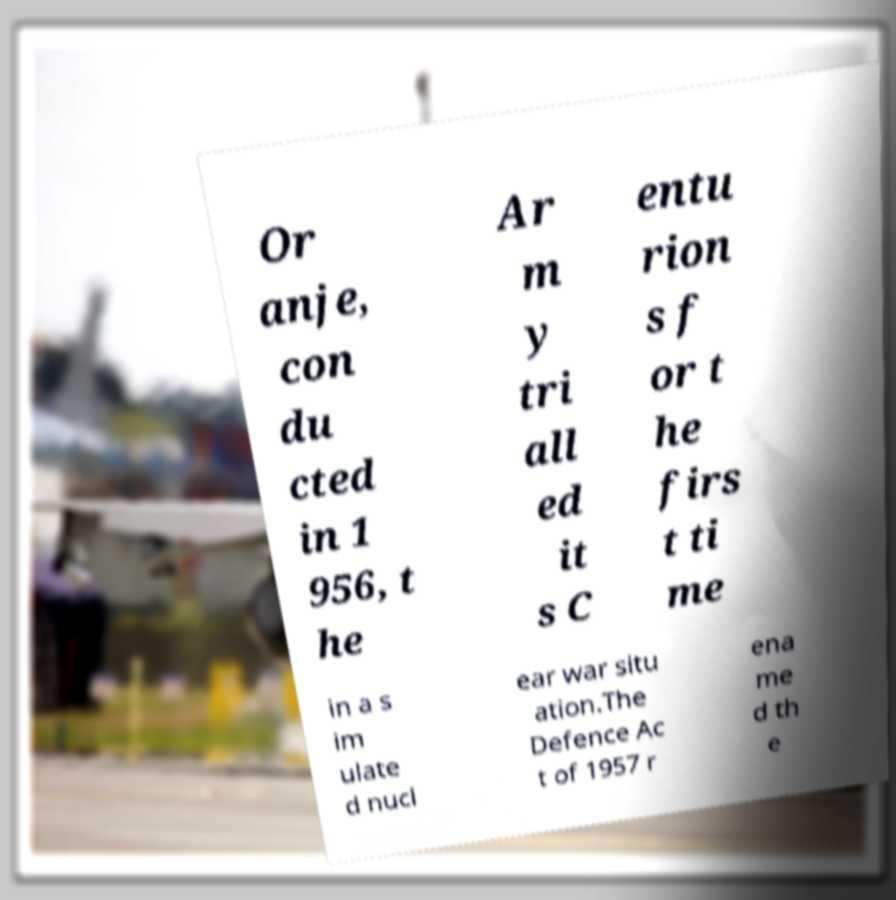Please identify and transcribe the text found in this image. Or anje, con du cted in 1 956, t he Ar m y tri all ed it s C entu rion s f or t he firs t ti me in a s im ulate d nucl ear war situ ation.The Defence Ac t of 1957 r ena me d th e 